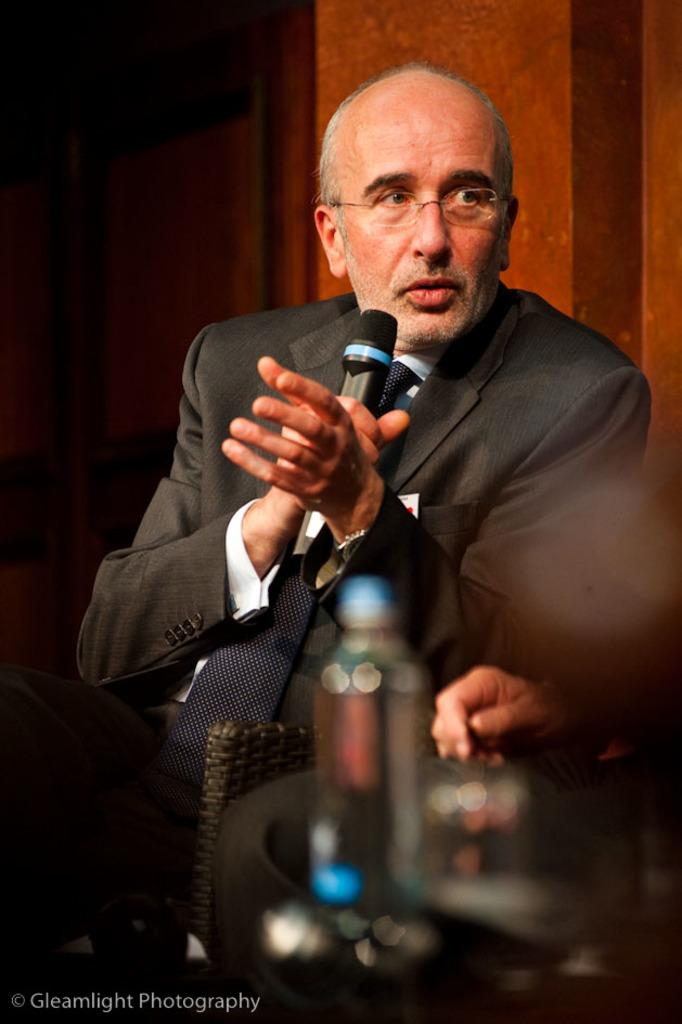Who is the main subject in the image? There is a man in the center of the image. What is the man wearing? The man is wearing a suit. What object is the man holding in his hand? The man is holding a microphone in his hand. What is the man doing with the microphone? The man is speaking on the microphone. What type of food is being cooked in the volcano in the image? There is no volcano or food present in the image; it features a man holding a microphone and speaking. 